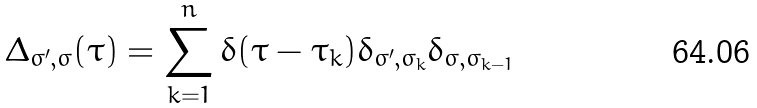Convert formula to latex. <formula><loc_0><loc_0><loc_500><loc_500>\Delta _ { \sigma ^ { \prime } , \sigma } ( \tau ) = \sum _ { k = 1 } ^ { n } \delta ( \tau - \tau _ { k } ) \delta _ { \sigma ^ { \prime } , \sigma _ { k } } \delta _ { \sigma , \sigma _ { k - 1 } }</formula> 